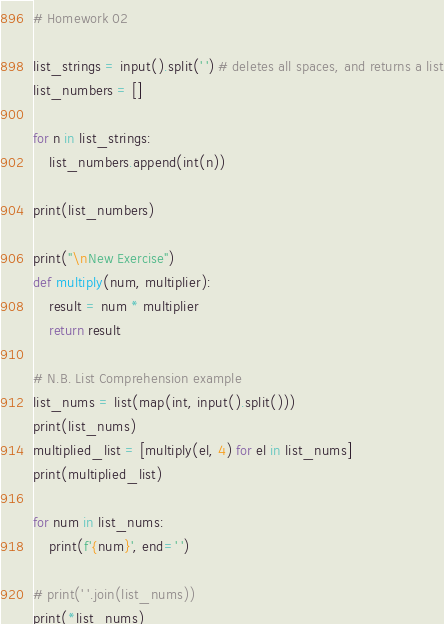Convert code to text. <code><loc_0><loc_0><loc_500><loc_500><_Python_># Homework 02

list_strings = input().split(' ') # deletes all spaces, and returns a list
list_numbers = []

for n in list_strings:
    list_numbers.append(int(n))

print(list_numbers)

print("\nNew Exercise")
def multiply(num, multiplier):
    result = num * multiplier
    return result

# N.B. List Comprehension example
list_nums = list(map(int, input().split()))
print(list_nums)
multiplied_list = [multiply(el, 4) for el in list_nums]
print(multiplied_list)

for num in list_nums:
    print(f'{num}', end=' ')

# print(' '.join(list_nums))
print(*list_nums)

</code> 